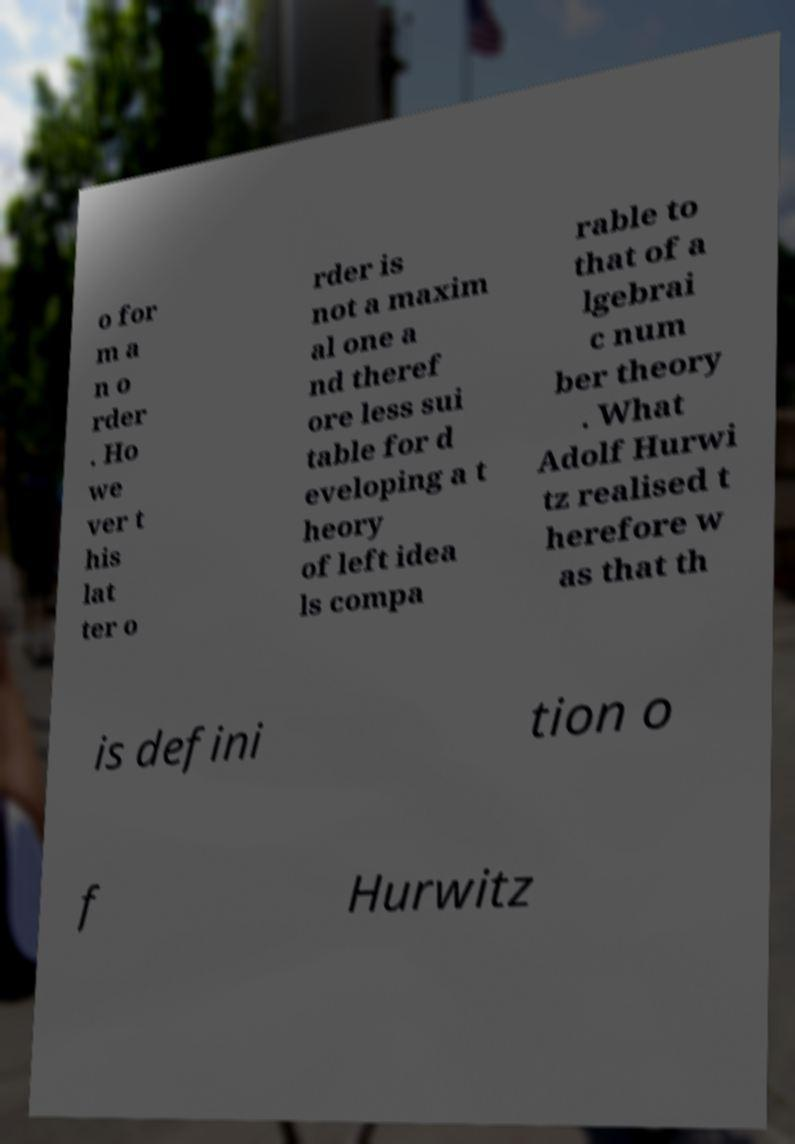Could you extract and type out the text from this image? o for m a n o rder . Ho we ver t his lat ter o rder is not a maxim al one a nd theref ore less sui table for d eveloping a t heory of left idea ls compa rable to that of a lgebrai c num ber theory . What Adolf Hurwi tz realised t herefore w as that th is defini tion o f Hurwitz 